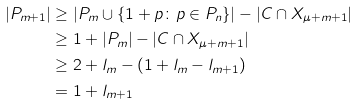<formula> <loc_0><loc_0><loc_500><loc_500>| P _ { m + 1 } | & \geq | P _ { m } \cup \{ 1 + p \colon p \in P _ { n } \} | - | C \cap X _ { \mu + m + 1 } | \\ & \geq 1 + | P _ { m } | - | C \cap X _ { \mu + m + 1 } | \\ & \geq 2 + l _ { m } - ( 1 + l _ { m } - l _ { m + 1 } ) \\ & = 1 + l _ { m + 1 }</formula> 